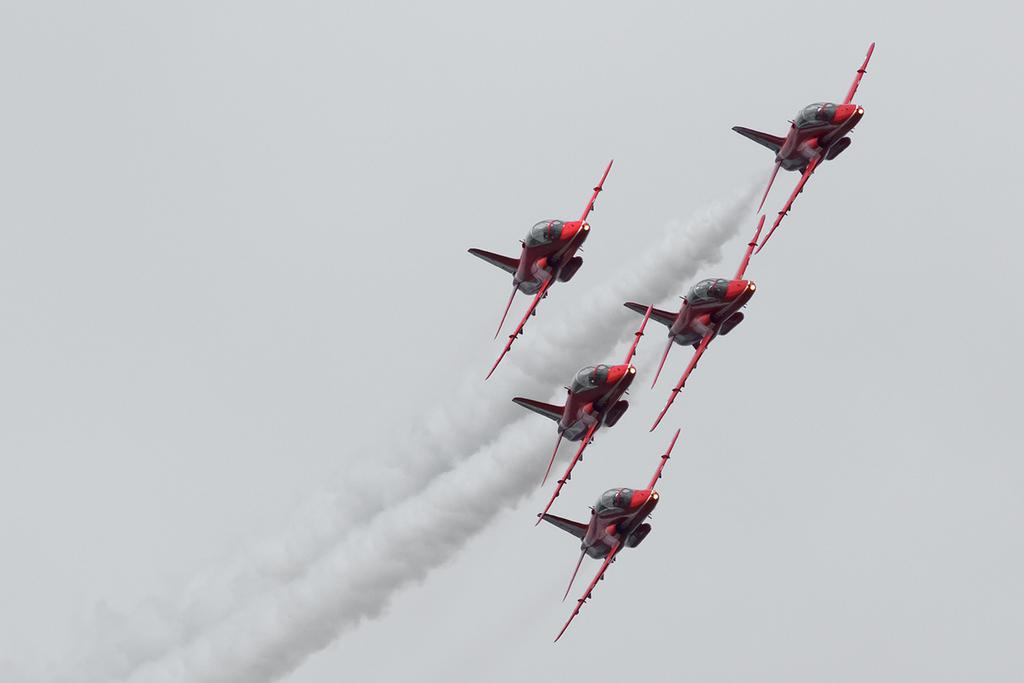What is the main subject of the image? The main subject of the image is a group of airplanes. What are the airplanes doing in the image? The airplanes are flying in the sky. What does the sister of the creator of the airplanes smell like in the image? There is no reference to a sister or a creator in the image, so it is not possible to answer that question. 